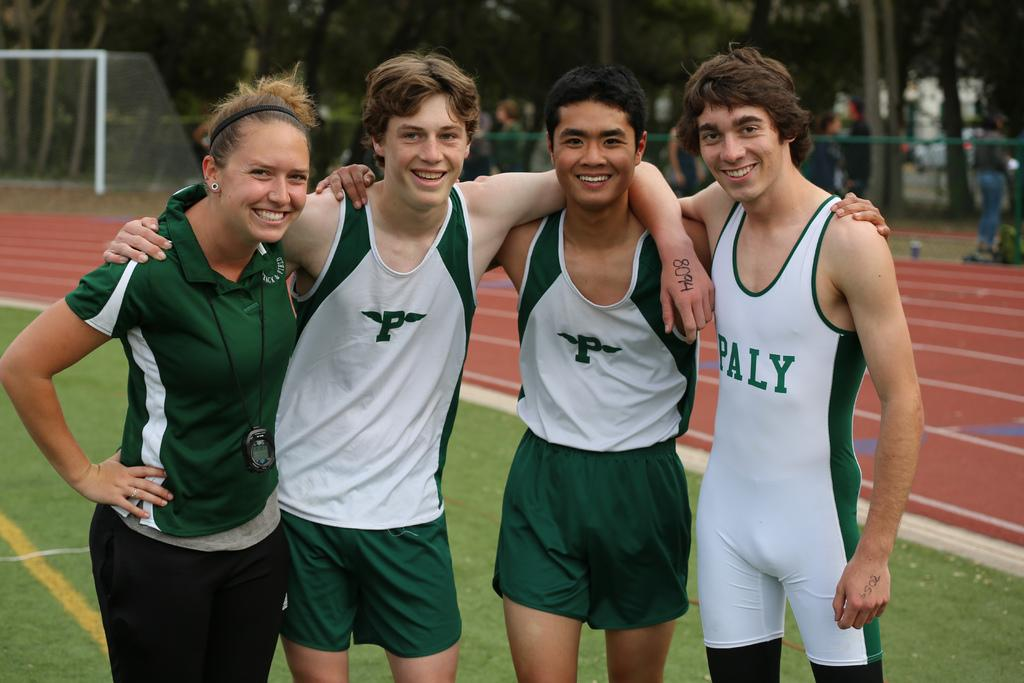<image>
Describe the image concisely. The kids on the track team most likely run for Paly. 